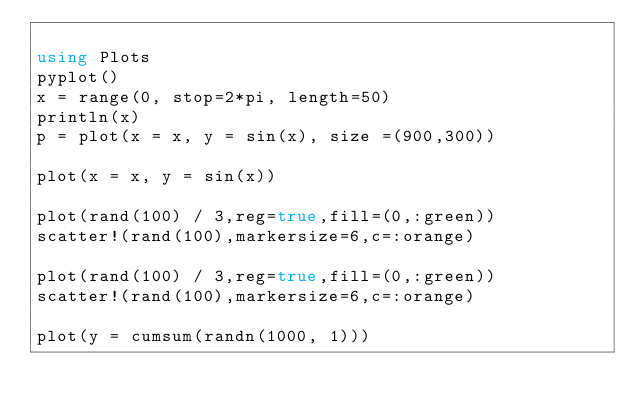<code> <loc_0><loc_0><loc_500><loc_500><_Julia_>
using Plots
pyplot()
x = range(0, stop=2*pi, length=50)
println(x)
p = plot(x = x, y = sin(x), size =(900,300))

plot(x = x, y = sin(x))

plot(rand(100) / 3,reg=true,fill=(0,:green))
scatter!(rand(100),markersize=6,c=:orange)

plot(rand(100) / 3,reg=true,fill=(0,:green))
scatter!(rand(100),markersize=6,c=:orange)

plot(y = cumsum(randn(1000, 1)))
</code> 